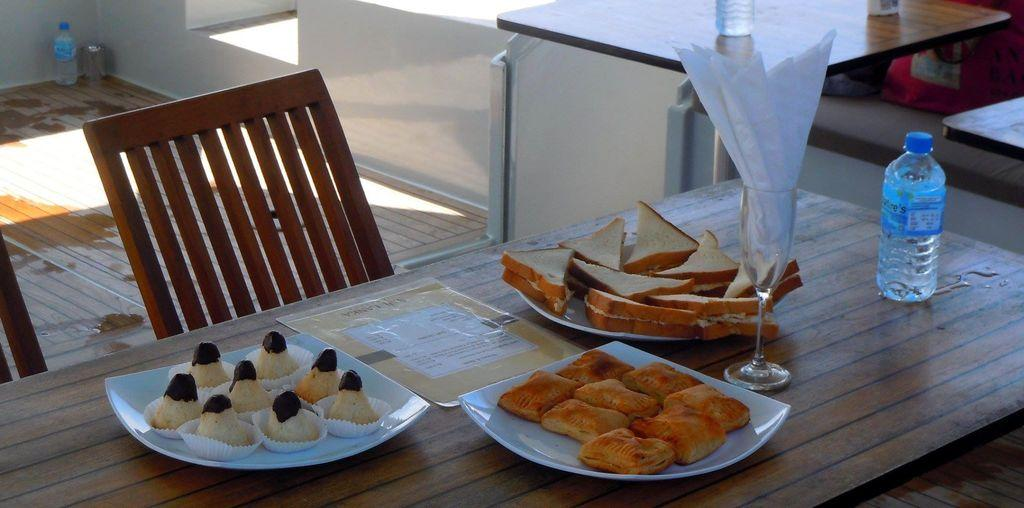What piece of furniture is present in the image? There is a table in the image. What items are placed on the table? There are plates, food, a glass, and a bottle on the table. Is there any seating visible in the image? Yes, there is a chair in the image. What part of the room can be seen in the image? The floor is visible in the image. How much debt is the table in the image responsible for? The table in the image is not responsible for any debt, as debt is a financial concept and not a characteristic of a table. --- Facts: 1. There is a person in the image. 2. The person is wearing a hat. 3. The person is holding a book. 4. There is a tree in the background of the image. 5. The sky is visible in the image. Absurd Topics: parrot, volcano, dance Conversation: What is the main subject of the image? The main subject of the image is a person. What is the person wearing in the image? The person is wearing a hat in the image. What object is the person holding in the image? The person is holding a book in the image. What can be seen in the background of the image? There is a tree in the background of the image. What part of the natural environment is visible in the image? The sky is visible in the image. Reasoning: Let's think step by step in order to produce the conversation. We start by identifying the main subject of the image, which is the person. Then, we describe the person's clothing and the object they are holding, which is a hat and a book, respectively. Next, we mention the presence of a tree in the background, which provides context for the setting. Finally, we acknowledge the visibility of the sky, which is another aspect of the natural environment. Absurd Question/Answer: Can you tell me how many parrots are sitting on the person's shoulder in the image? There are no parrots present in the image, so it is not possible to determine the number of parrots on the person's shoulder. 